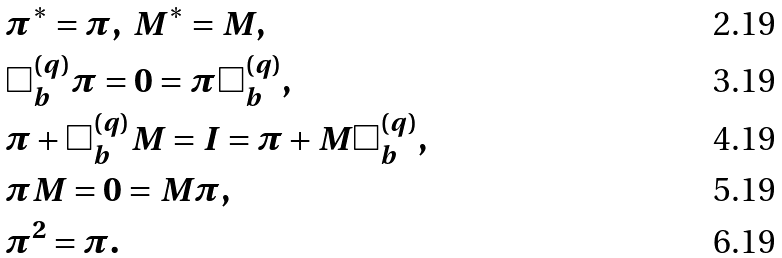<formula> <loc_0><loc_0><loc_500><loc_500>& \pi ^ { * } = \pi , \ M ^ { * } = M , \\ & \Box ^ { ( q ) } _ { b } \pi = 0 = \pi \Box ^ { ( q ) } _ { b } , \\ & \pi + \Box ^ { ( q ) } _ { b } M = I = \pi + M \Box ^ { ( q ) } _ { b } , \\ & \pi M = 0 = M \pi , \\ & \pi ^ { 2 } = \pi .</formula> 